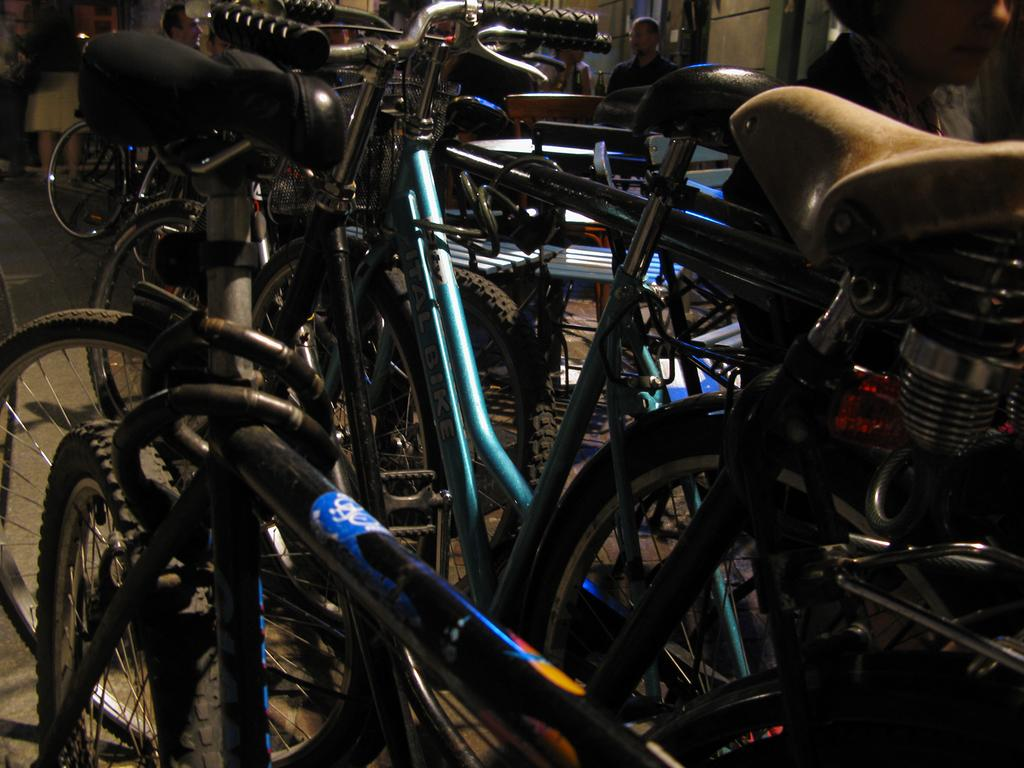What is the main subject in the center of the image? There are bicycles in the center of the image. What can be seen in the background of the image? There are persons visible in the background of the image, and there is a wall in the background as well. What part of the image shows the floor? The floor is visible on the left side of the image. Can you see any cobwebs on the bicycles in the image? There is no mention of cobwebs in the image, so we cannot determine if they are present or not. 